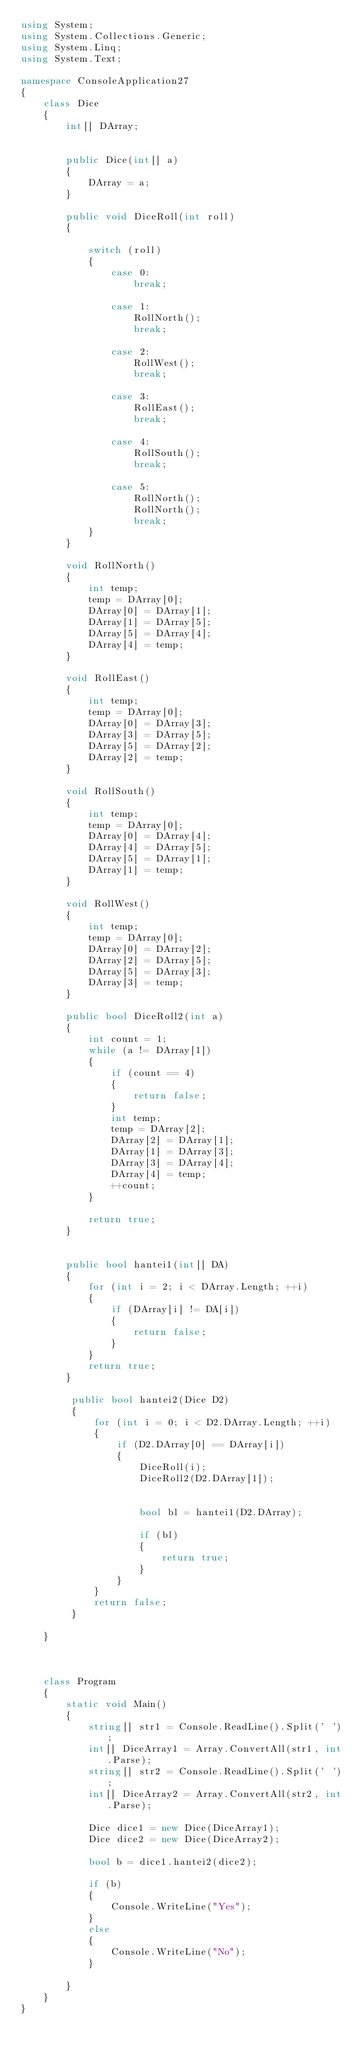Convert code to text. <code><loc_0><loc_0><loc_500><loc_500><_C#_>using System;
using System.Collections.Generic;
using System.Linq;
using System.Text;

namespace ConsoleApplication27
{
    class Dice
    {
        int[] DArray;


        public Dice(int[] a)
        {
            DArray = a;
        }

        public void DiceRoll(int roll)
        {

            switch (roll)
            {
                case 0:
                    break;

                case 1:
                    RollNorth();
                    break;

                case 2:
                    RollWest();
                    break;

                case 3:
                    RollEast();
                    break;

                case 4:
                    RollSouth();
                    break;

                case 5:
                    RollNorth();
                    RollNorth();
                    break;
            }
        }

        void RollNorth()
        {
            int temp;
            temp = DArray[0];
            DArray[0] = DArray[1];
            DArray[1] = DArray[5];
            DArray[5] = DArray[4];
            DArray[4] = temp;
        }

        void RollEast()
        {
            int temp;
            temp = DArray[0];
            DArray[0] = DArray[3];
            DArray[3] = DArray[5];
            DArray[5] = DArray[2];
            DArray[2] = temp;
        }

        void RollSouth()
        {
            int temp;
            temp = DArray[0];
            DArray[0] = DArray[4];
            DArray[4] = DArray[5];
            DArray[5] = DArray[1];
            DArray[1] = temp;
        }

        void RollWest()
        {
            int temp;
            temp = DArray[0];
            DArray[0] = DArray[2];
            DArray[2] = DArray[5];
            DArray[5] = DArray[3];
            DArray[3] = temp;
        }

        public bool DiceRoll2(int a)
        {
            int count = 1;
            while (a != DArray[1])
            {
                if (count == 4)
                {
                    return false;
                }
                int temp;
                temp = DArray[2];
                DArray[2] = DArray[1];
                DArray[1] = DArray[3];
                DArray[3] = DArray[4];
                DArray[4] = temp;
                ++count;
            }

            return true;
        }


        public bool hantei1(int[] DA)           
        {
            for (int i = 2; i < DArray.Length; ++i)
            {
                if (DArray[i] != DA[i])
                {
                    return false;
                }
            }
            return true;
        }

         public bool hantei2(Dice D2)
         {
             for (int i = 0; i < D2.DArray.Length; ++i)
             {
                 if (D2.DArray[0] == DArray[i])
                 {
                     DiceRoll(i);
                     DiceRoll2(D2.DArray[1]);


                     bool bl = hantei1(D2.DArray);

                     if (bl)
                     {
                         return true;
                     }
                 }
             }
             return false;
         }
   
    }
   


    class Program
    {
        static void Main()
        {
            string[] str1 = Console.ReadLine().Split(' ');
            int[] DiceArray1 = Array.ConvertAll(str1, int.Parse);
            string[] str2 = Console.ReadLine().Split(' ');
            int[] DiceArray2 = Array.ConvertAll(str2, int.Parse);

            Dice dice1 = new Dice(DiceArray1);
            Dice dice2 = new Dice(DiceArray2);

            bool b = dice1.hantei2(dice2);

            if (b)
            {
                Console.WriteLine("Yes");
            }
            else
            {
                Console.WriteLine("No");
            }

        }
    }
}</code> 